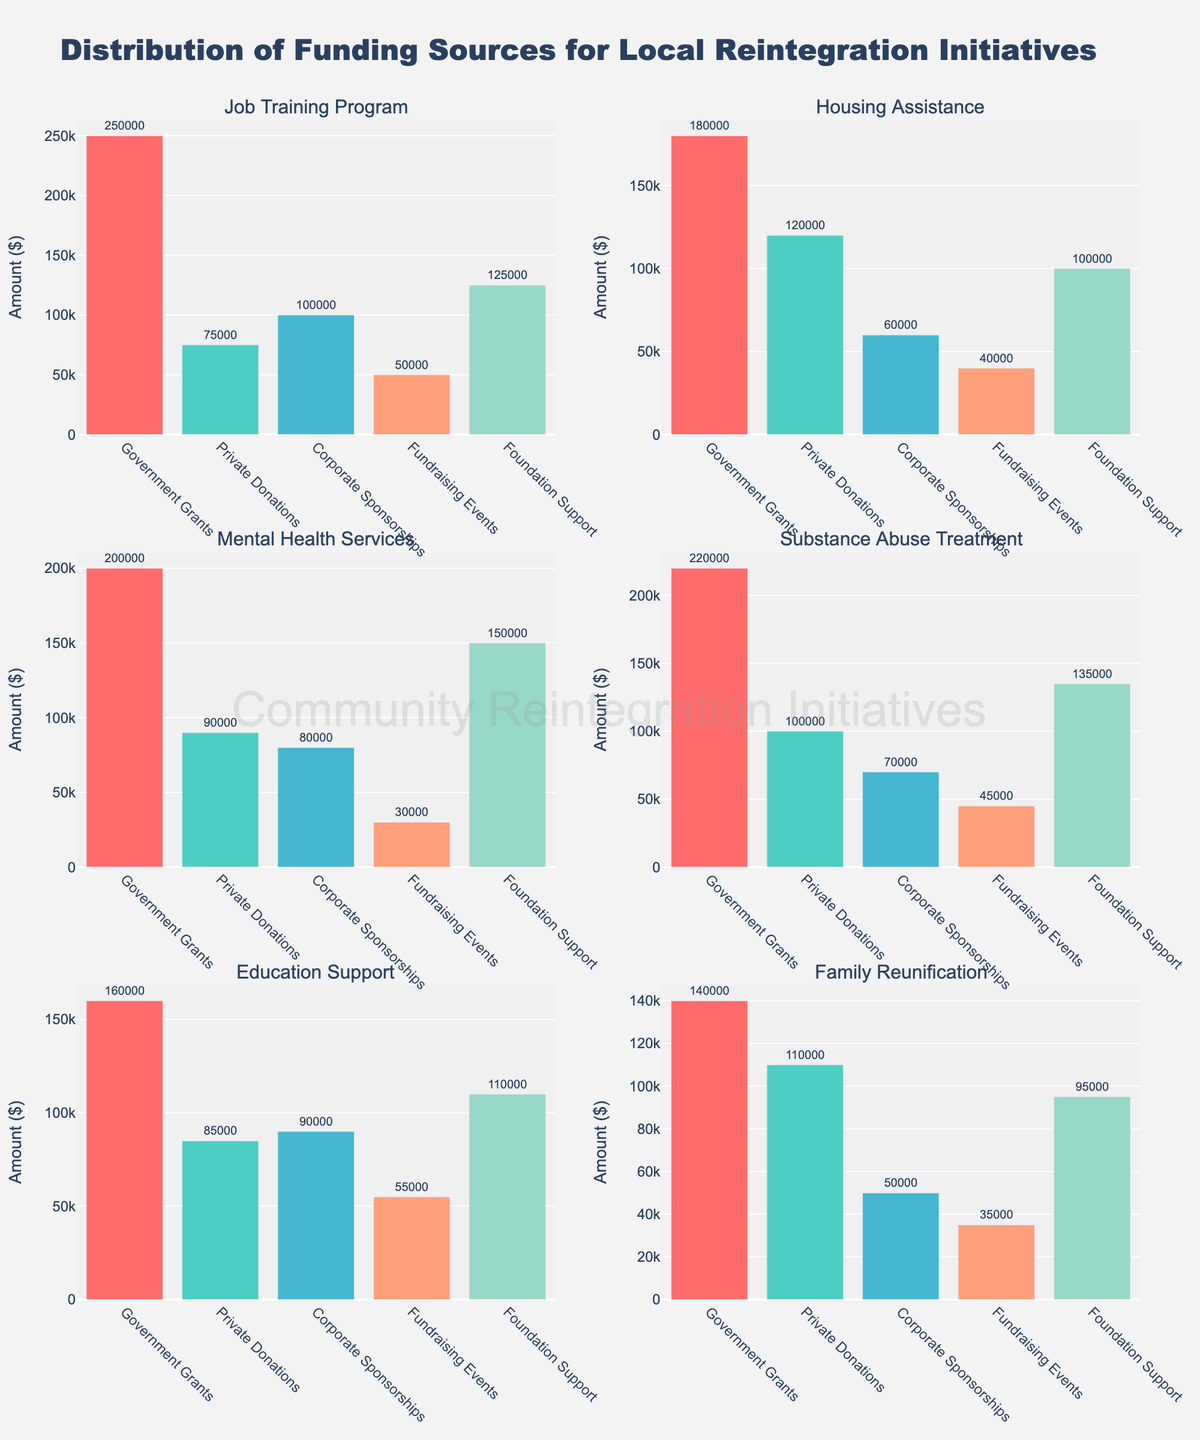What are the initiatives supported by Government Grants? Refer to the titles of each subplot to identify the initiatives, all of them show bar heights representing Government Grants.
Answer: Job Training Program, Housing Assistance, Mental Health Services, Substance Abuse Treatment, Education Support, Family Reunification Which funding source has the highest value in the Job Training Program? Check the bar heights in the Job Training Program subplot. The highest bar corresponds to Government Grants.
Answer: Government Grants What is the average amount funded by Private Donations across all initiatives? Add all the values for Private Donations across the initiatives (75000 + 120000 + 90000 + 100000 + 85000 + 110000 = 580000) and divide by the number of initiatives (6).
Answer: 96666.67 How much more does the Mental Health Services initiative receive from Foundation Support compared to Fundraising Events? Subtract the Fundraising Events value from the Foundation Support value in the Mental Health Services subplot (150000 - 30000).
Answer: 120000 Which initiative received the least amount from Corporate Sponsorships? Compare the bar heights for Corporate Sponsorships in each subplot to find the smallest, which is Family Reunification.
Answer: Family Reunification What is the total amount funded to Substance Abuse Treatment from Government Grants and Private Donations combined? Add the values for Government Grants and Private Donations in the Substance Abuse Treatment subplot (220000 + 100000).
Answer: 320000 In the Education Support initiative, are the amounts funded from Foundation Support and Private Donations equal? Check the bar heights for Foundation Support and Private Donations in the Education Support subplot. They are not equal as Foundation Support is 110000 and Private Donations are 85000.
Answer: No Which two funding sources provide equal amounts for Family Reunification? Compare the bar heights in Family Reunification, Corporate Sponsorships and Fundraising Events both have bars of height 50000 and 35000 respectively.
Answer: None Among all initiatives, which one has the highest total funding amount? Sum the values of all funding sources for each initiative and compare them: Job Training Program (600000), Housing Assistance (500000), Mental Health Services (550000), Substance Abuse Treatment (570000), Education Support (500000), Family Reunification (420000). The highest total is for Job Training Program.
Answer: Job Training Program 